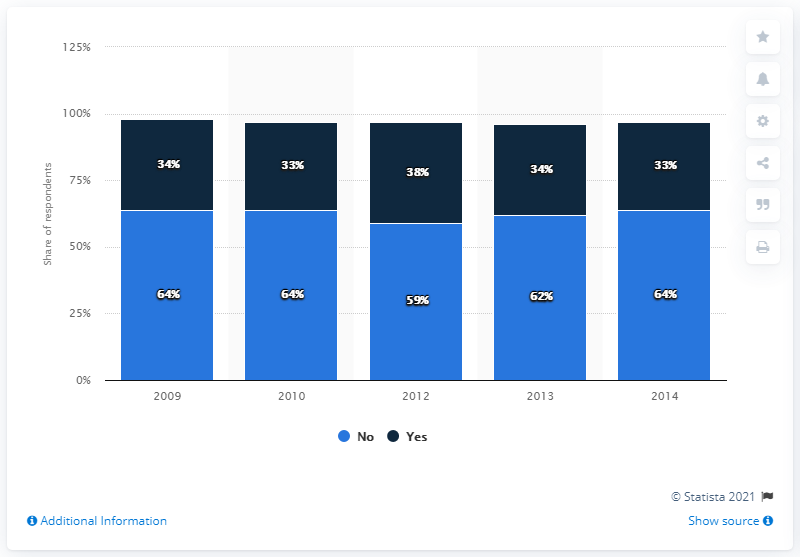Identify some key points in this picture. Thirty-four percent of respondents indicated that they will be watching the Super Bowl in 2012. The median value of the light blue bars is equal to 64, indicating that the data points in this group are evenly distributed. 